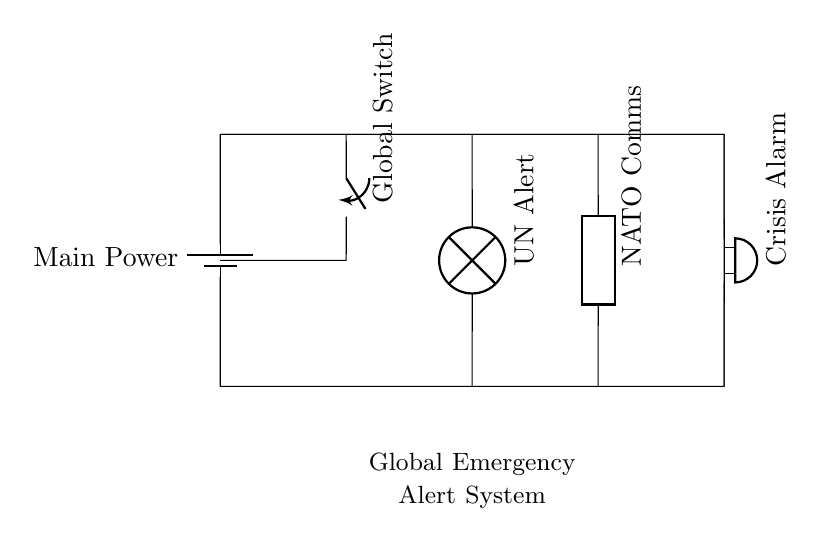What is the main power source in this circuit? The circuit diagram indicates a battery as the main power source, specifically labeled as "Main Power."
Answer: Battery What are the three alert systems connected in the circuit? The circuit contains three alert systems: "UN Alert," "NATO Comms," and "Crisis Alarm." Each is represented by different components (lamp, generic, and buzzer).
Answer: UN Alert, NATO Comms, Crisis Alarm How many switches are present in the circuit? There is one switch labeled as "Global Switch," which controls the flow of electricity within the circuit.
Answer: One What is the purpose of the "Global Switch"? The "Global Switch" serves as a control mechanism that can activate or deactivate the entire alert system, affecting all connected components at once.
Answer: Control mechanism Which component provides audio signaling in the circuit? The "Crisis Alarm" component, identified as a buzzer, is responsible for providing audio alerts in the event of a crisis.
Answer: Buzzer 